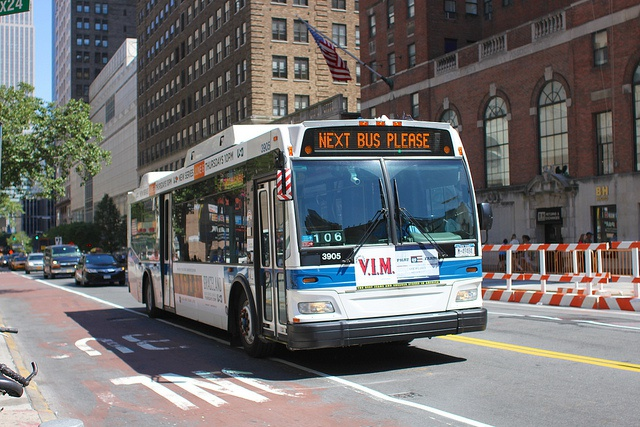Describe the objects in this image and their specific colors. I can see bus in darkgreen, black, white, darkgray, and gray tones, car in darkgreen, black, blue, and gray tones, car in darkgreen, gray, blue, and black tones, people in darkgreen, black, maroon, gray, and brown tones, and car in darkgreen, gray, lightgray, blue, and darkgray tones in this image. 